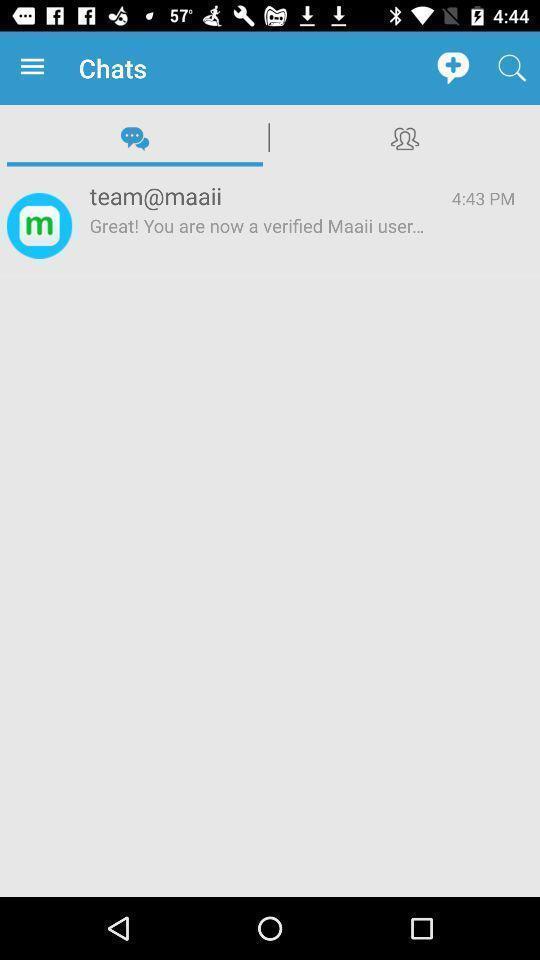Please provide a description for this image. Screen displaying the chats page. 